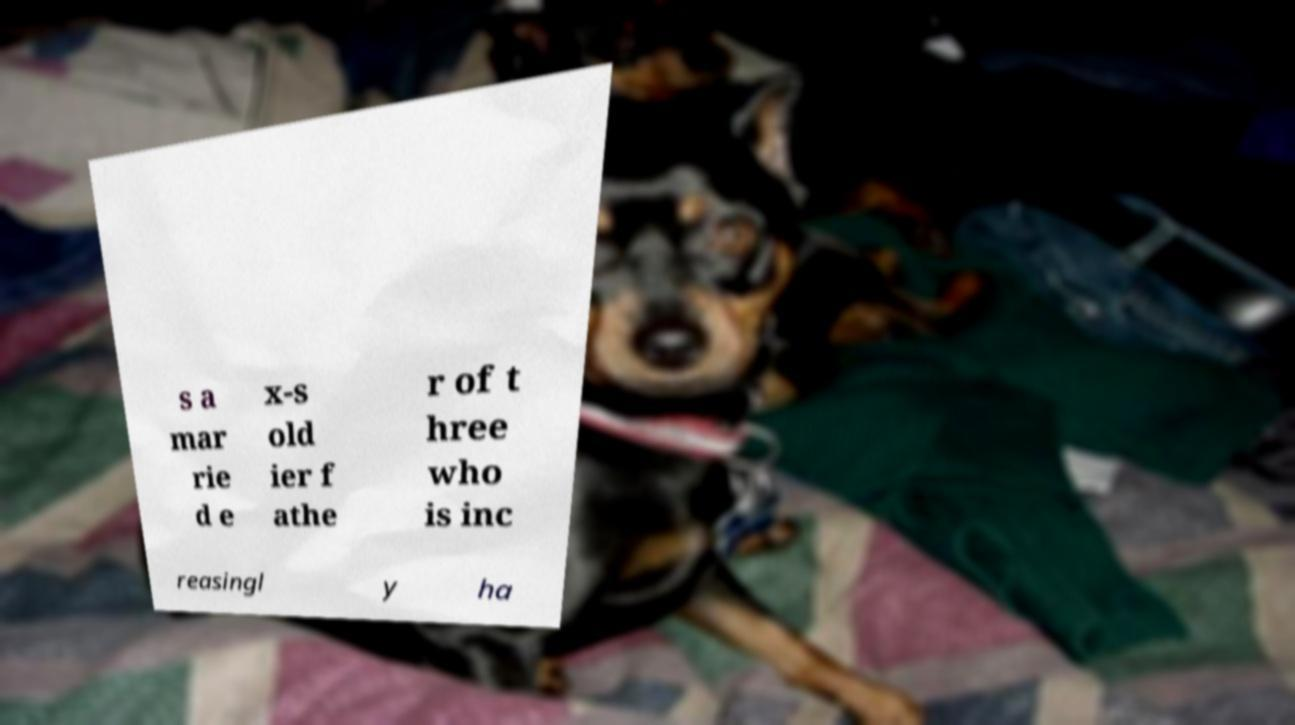There's text embedded in this image that I need extracted. Can you transcribe it verbatim? s a mar rie d e x-s old ier f athe r of t hree who is inc reasingl y ha 